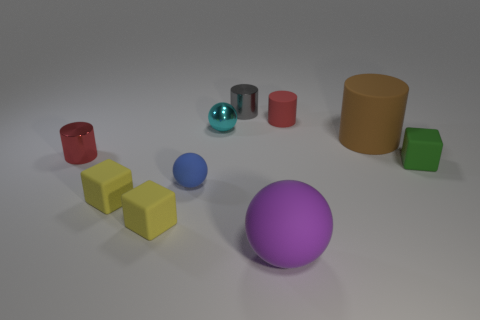Subtract 1 spheres. How many spheres are left? 2 Subtract all big brown matte cylinders. How many cylinders are left? 3 Subtract all gray cylinders. How many cylinders are left? 3 Subtract all cyan cylinders. Subtract all purple cubes. How many cylinders are left? 4 Subtract all cylinders. How many objects are left? 6 Add 9 large brown matte objects. How many large brown matte objects are left? 10 Add 5 small blue spheres. How many small blue spheres exist? 6 Subtract 0 brown balls. How many objects are left? 10 Subtract all tiny brown rubber blocks. Subtract all cylinders. How many objects are left? 6 